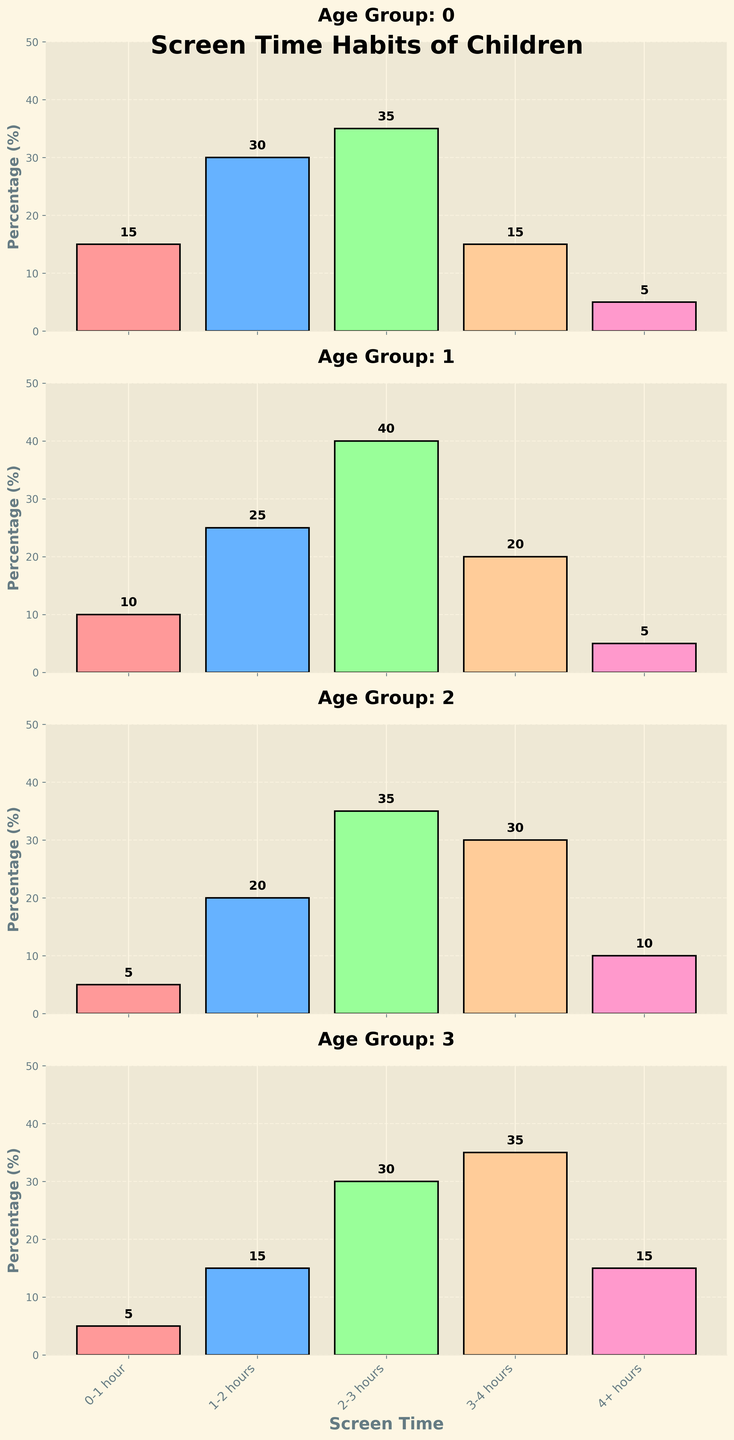Which age group has the highest percentage of children spending 2-3 hours on screen? Observe the bar heights for the 2-3 hours category in each age group. The highest bar is at the 13-16 years category with a height of 30%.
Answer: 13-16 years Which age group has the least percentage of children spending 0-1 hour on screen? Look at the bars for 0-1 hour in each subplot. The 10-12 and 13-16 years groups both have the lowest, with a 5% height.
Answer: 10-12 and 13-16 years What is the total percentage of children aged 6-9 years that spend between 1-4 hours on screens? Add the percentages for the bars representing 1-2 hours, 2-3 hours, and 3-4 hours: 25% + 40% + 20% = 85%.
Answer: 85% In which age group do most children spend 4+ hours on screen? Identify the highest bar in the 4+ hours category. The tallest bar is in the 13-16 years age group with a height of 15%.
Answer: 13-16 years Compare the screen time of 0-1 hour between 2-5 years and 6-9 years. Which group has a higher percentage? Compare the bar heights for 0-1 hour: 2-5 years (15%) and 6-9 years (10%). 2-5 years has a higher percentage.
Answer: 2-5 years How many age groups have 30% or more children spending 3-4 hours on the screen? Observe the bars in each subplot for 3-4 hours. Two groups, 10-12 (30%) and 13-16 (35%) meet this criterion.
Answer: 2 What is the average percentage of children spending 1-2 hours on screens across all age groups? Add the values for 1-2 hours from all age groups: 30% + 25% + 20% + 15% = 90%. Divide by 4: 90% / 4 = 22.5%.
Answer: 22.5% Which age group has a higher variability in screen time habits, 2-5 years or 13-16 years? Compare the spread and height differences of all bars in both age group subplots. 13-16 years shows more variety across categories.
Answer: 13-16 years For the age group 10-12 years, what is the difference between the percentage of children spending 3-4 hours and those spending 4+ hours? Locate the bars for 3-4 hours (30%) and 4+ hours (10%) and calculate the difference: 30% - 10% = 20%.
Answer: 20% 